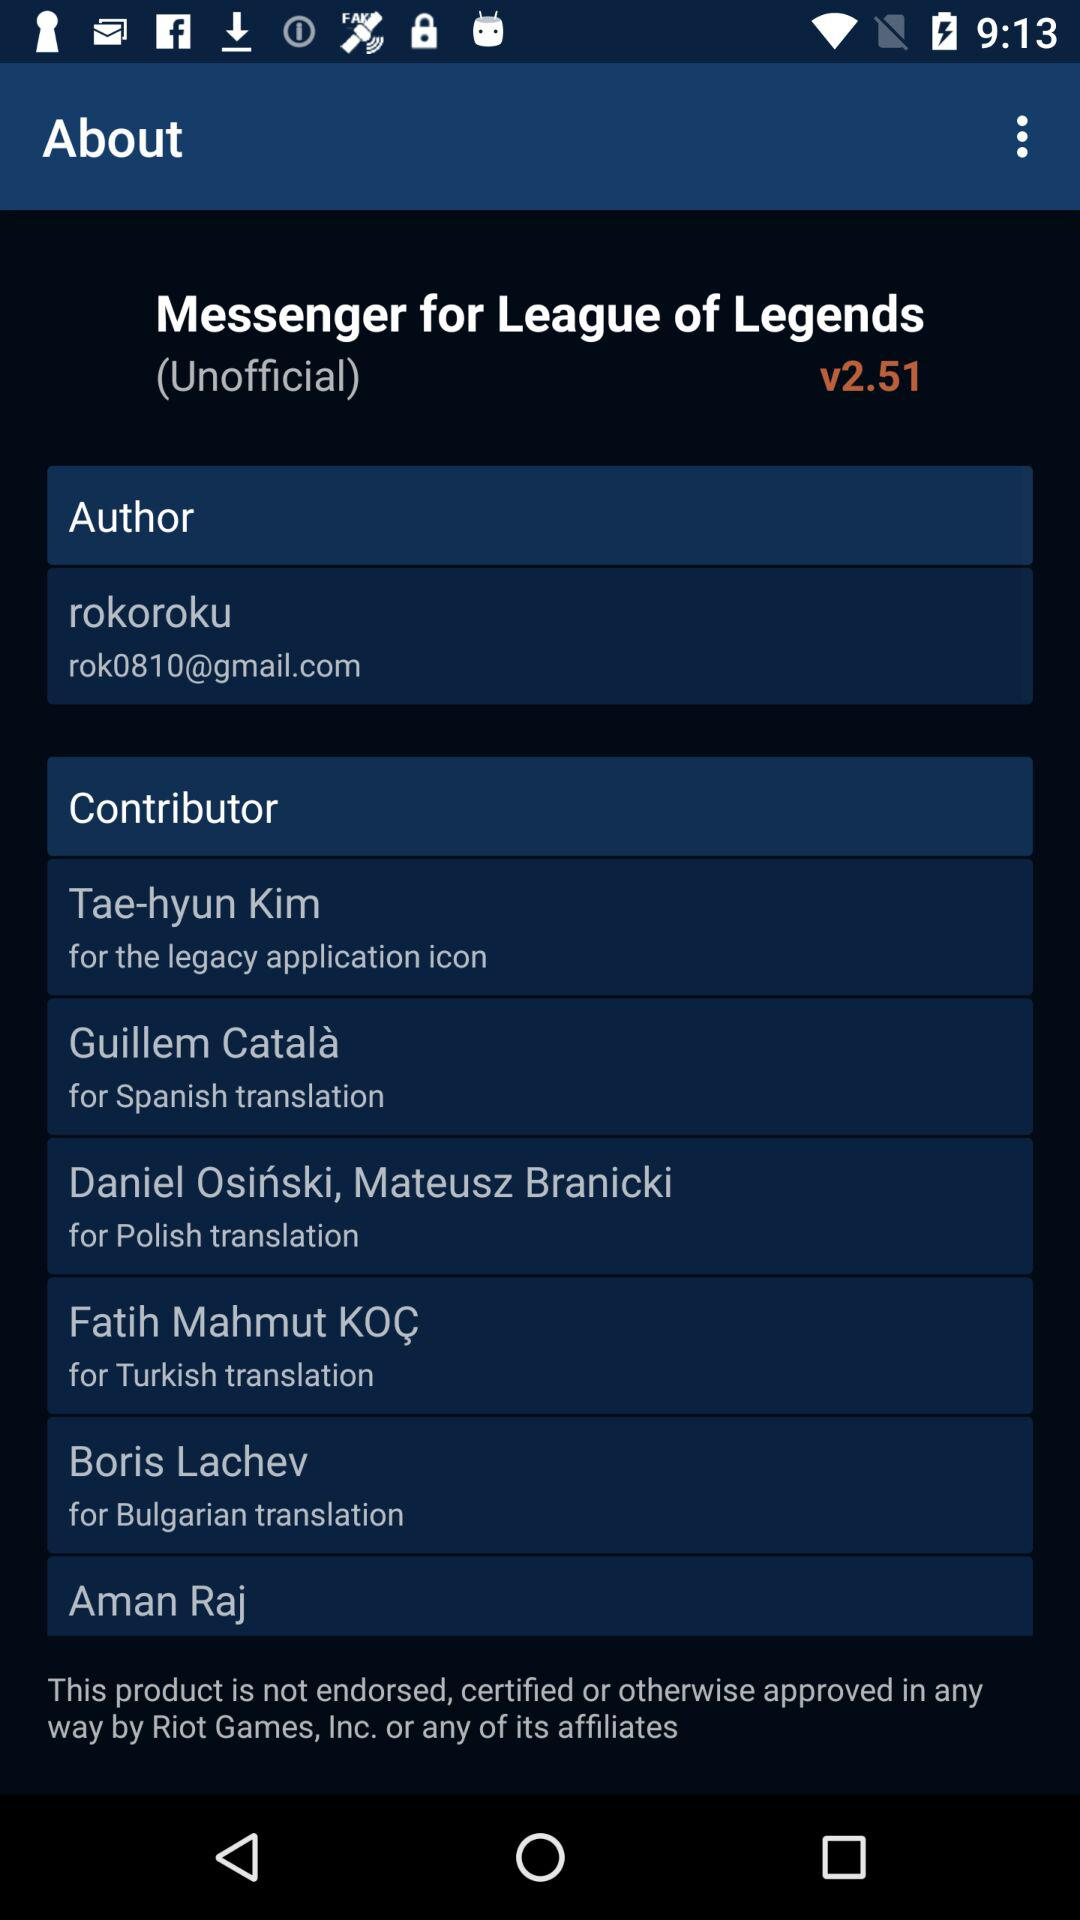Who is the contributor for the Bulgarian translation? The contributor is Boris Lachev. 